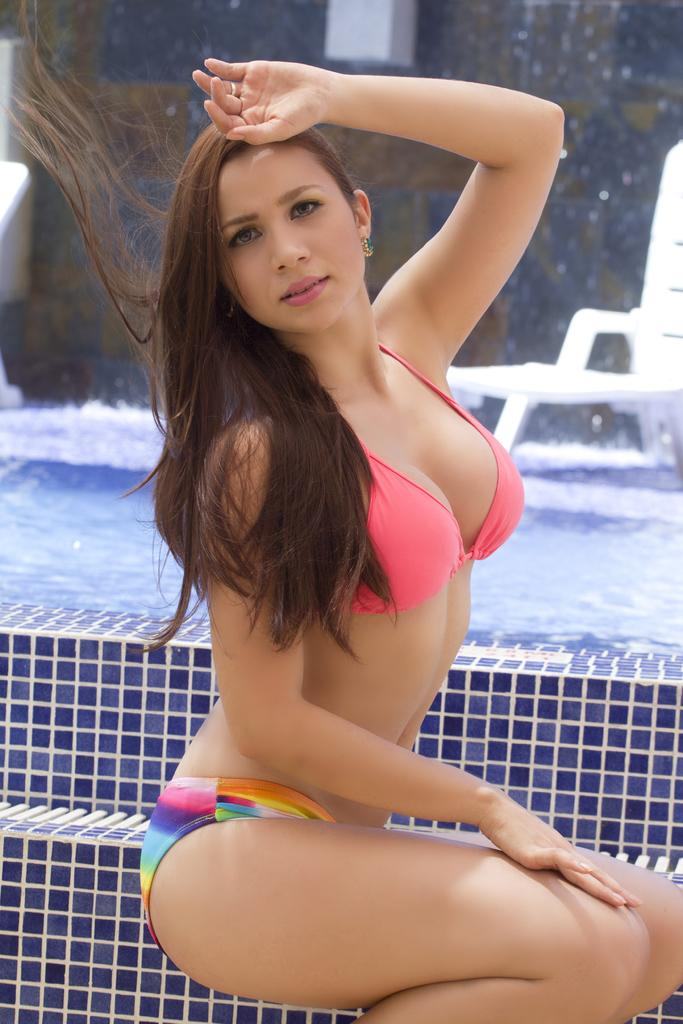Who is present in the image? There is a woman in the image. What is the woman doing in the image? The woman is sitting on the floor. What can be seen in the background of the image? There is a swimming pool visible in the background of the image. What type of amusement can be seen in the image? There is no amusement present in the image; it features a woman sitting on the floor with a swimming pool in the background. Can you tell me how many snakes are visible in the image? There are no snakes present in the image. 